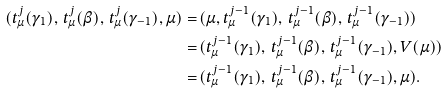<formula> <loc_0><loc_0><loc_500><loc_500>( t _ { \mu } ^ { j } ( \gamma _ { 1 } ) , \, t _ { \mu } ^ { j } ( { \beta } ) , \, t _ { \mu } ^ { j } ( { \gamma _ { - 1 } } ) , \mu ) = \, & ( \mu , t _ { \mu } ^ { j - 1 } ( \gamma _ { 1 } ) , \, t _ { \mu } ^ { j - 1 } ( { \beta } ) , \, t _ { \mu } ^ { j - 1 } ( { \gamma _ { - 1 } } ) ) \\ = \, & ( t _ { \mu } ^ { j - 1 } ( \gamma _ { 1 } ) , \, t _ { \mu } ^ { j - 1 } ( { \beta } ) , \, t _ { \mu } ^ { j - 1 } ( { \gamma _ { - 1 } } ) , V ( \mu ) ) \\ = \, & ( t _ { \mu } ^ { j - 1 } ( \gamma _ { 1 } ) , \, t _ { \mu } ^ { j - 1 } ( { \beta } ) , \, t _ { \mu } ^ { j - 1 } ( { \gamma _ { - 1 } } ) , \mu ) .</formula> 